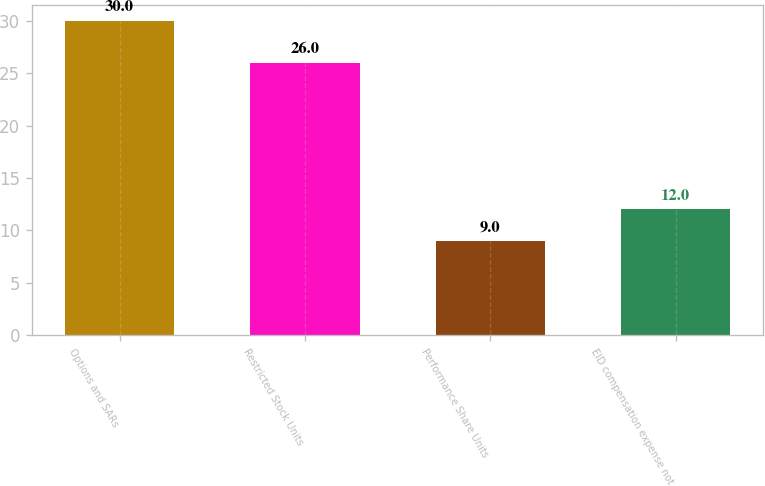<chart> <loc_0><loc_0><loc_500><loc_500><bar_chart><fcel>Options and SARs<fcel>Restricted Stock Units<fcel>Performance Share Units<fcel>EID compensation expense not<nl><fcel>30<fcel>26<fcel>9<fcel>12<nl></chart> 